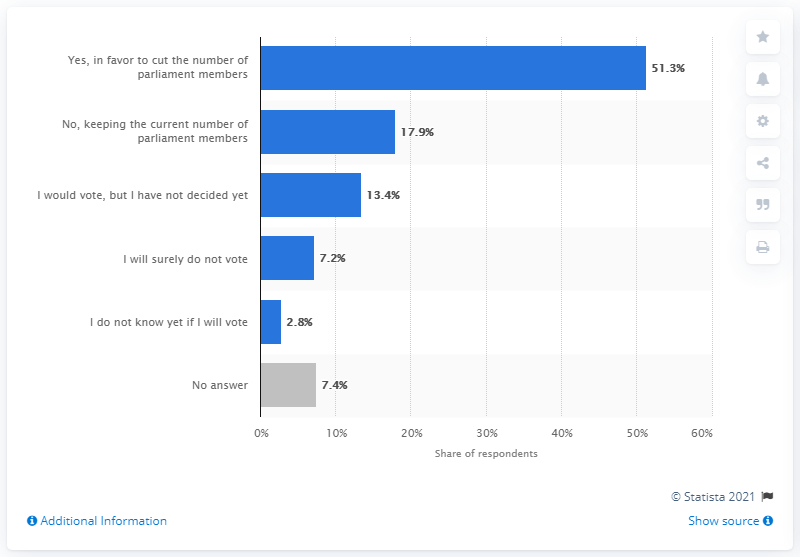Identify some key points in this picture. A majority of respondents, 51.3%, indicated their intention to vote in favor of reducing the number of parliament members. 